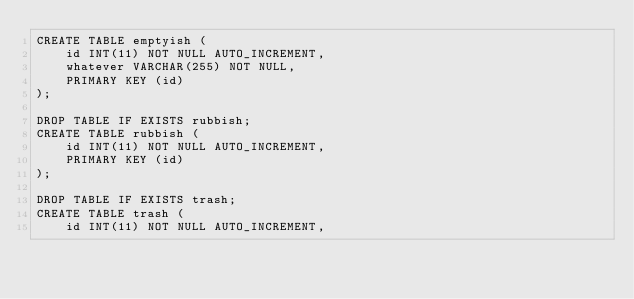<code> <loc_0><loc_0><loc_500><loc_500><_SQL_>CREATE TABLE emptyish (
    id INT(11) NOT NULL AUTO_INCREMENT,
    whatever VARCHAR(255) NOT NULL,
    PRIMARY KEY (id)
);

DROP TABLE IF EXISTS rubbish;
CREATE TABLE rubbish (
    id INT(11) NOT NULL AUTO_INCREMENT,
    PRIMARY KEY (id)
);

DROP TABLE IF EXISTS trash;
CREATE TABLE trash (
    id INT(11) NOT NULL AUTO_INCREMENT,</code> 